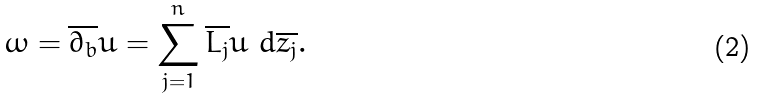Convert formula to latex. <formula><loc_0><loc_0><loc_500><loc_500>\omega = { \overline { { \partial _ { b } } } } u = \sum _ { j = 1 } ^ { n } { \overline { { L _ { j } } } } u \ d { \overline { { z _ { j } } } } .</formula> 